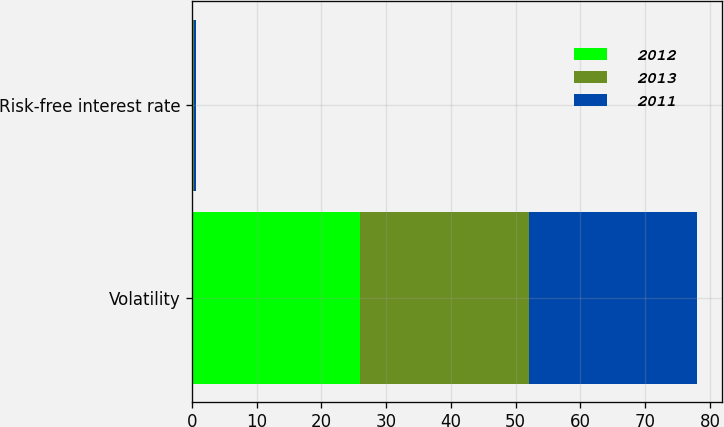Convert chart. <chart><loc_0><loc_0><loc_500><loc_500><stacked_bar_chart><ecel><fcel>Volatility<fcel>Risk-free interest rate<nl><fcel>2012<fcel>26<fcel>0.14<nl><fcel>2013<fcel>26<fcel>0.16<nl><fcel>2011<fcel>26<fcel>0.3<nl></chart> 